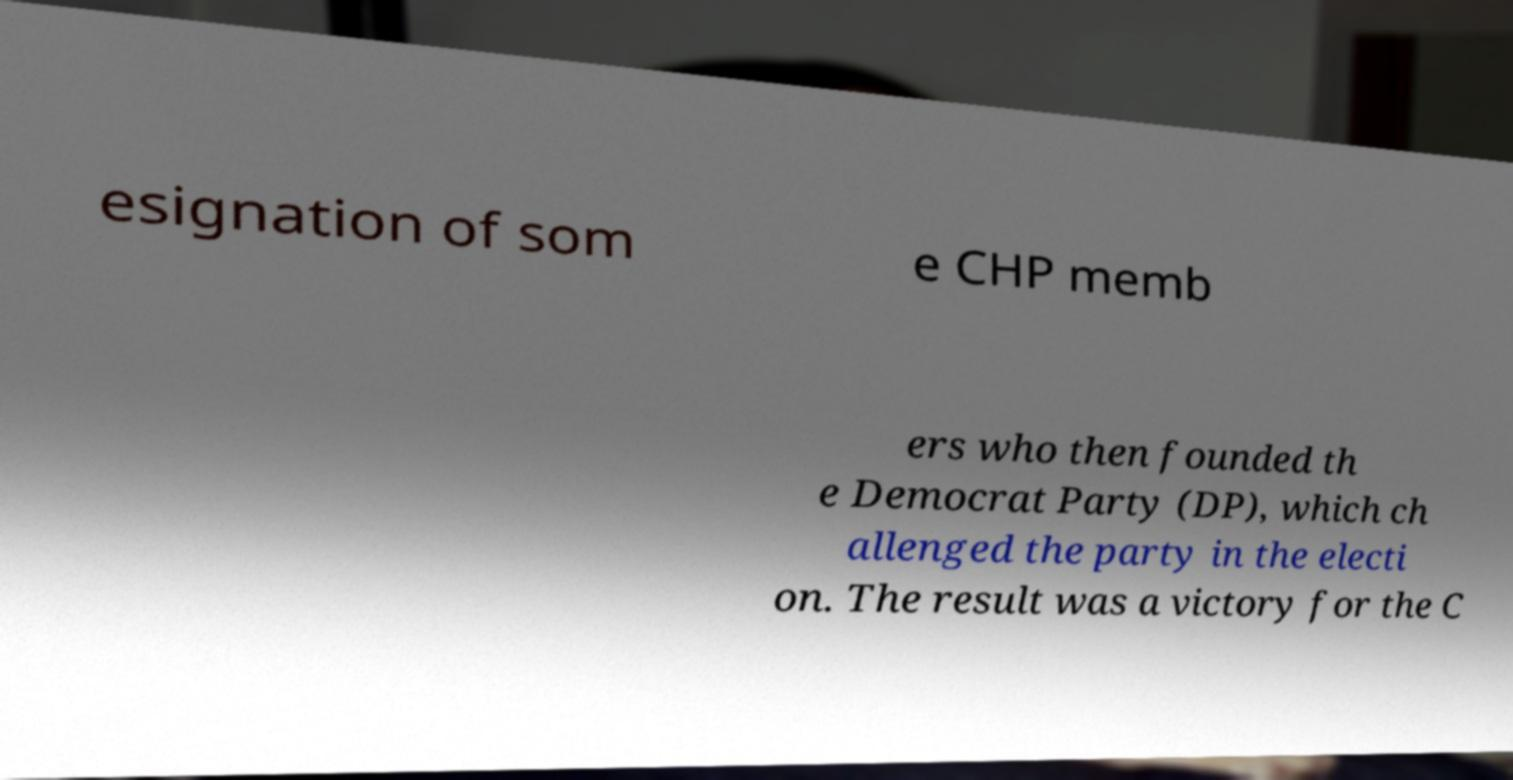There's text embedded in this image that I need extracted. Can you transcribe it verbatim? esignation of som e CHP memb ers who then founded th e Democrat Party (DP), which ch allenged the party in the electi on. The result was a victory for the C 